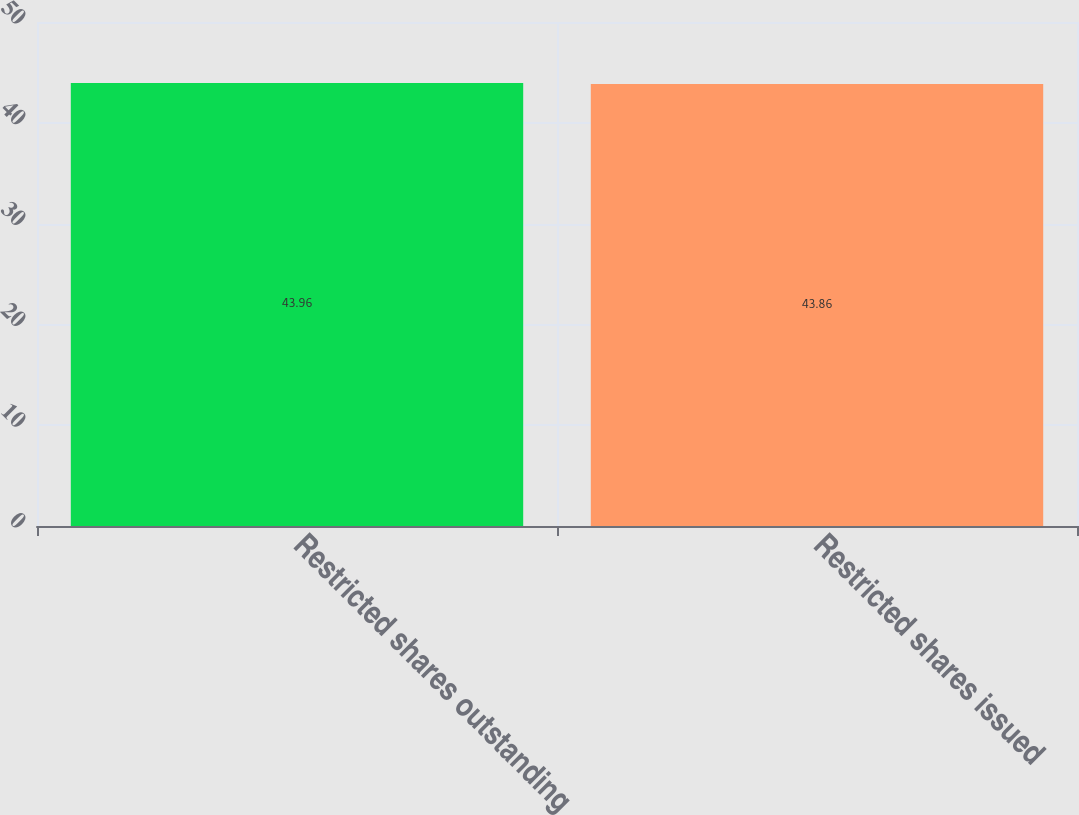<chart> <loc_0><loc_0><loc_500><loc_500><bar_chart><fcel>Restricted shares outstanding<fcel>Restricted shares issued<nl><fcel>43.96<fcel>43.86<nl></chart> 